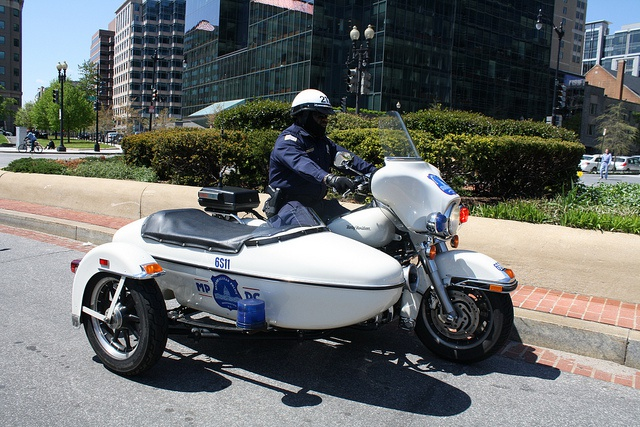Describe the objects in this image and their specific colors. I can see motorcycle in gray, black, white, and darkgray tones, people in gray, black, and navy tones, car in gray, white, darkgray, and black tones, car in gray, white, black, and darkgray tones, and traffic light in gray, black, blue, and navy tones in this image. 